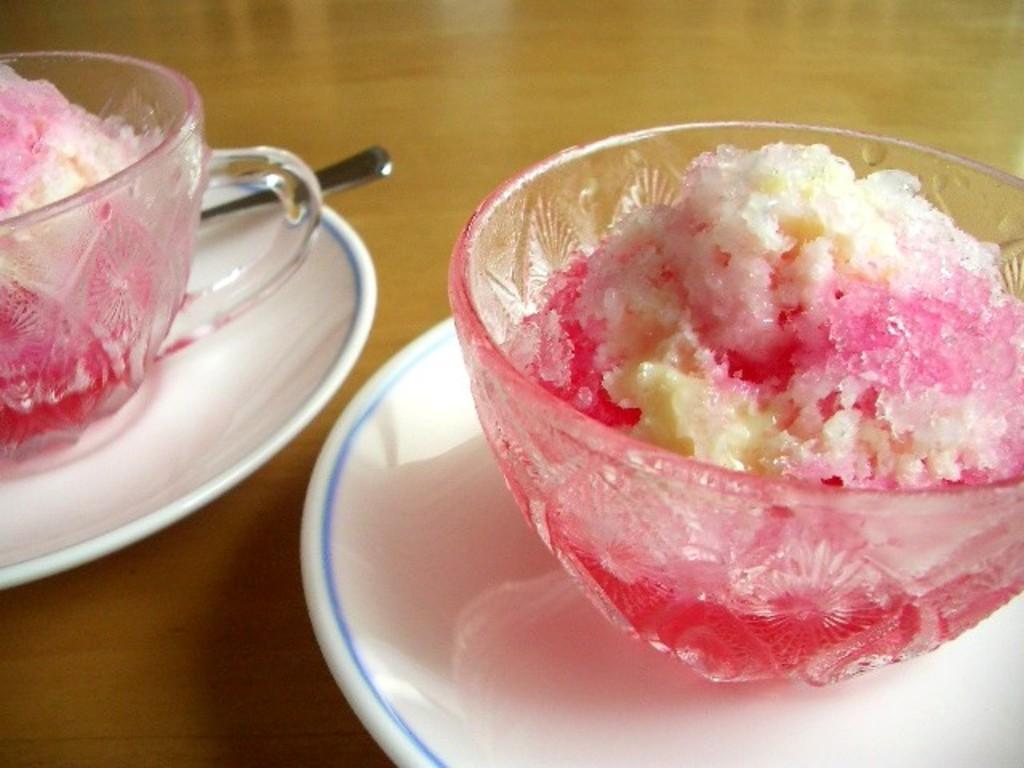Please provide a concise description of this image. In the foreground I can see two plates in which there are two ice cream bowls and a spoon kept on the table. This image is taken in a room. 